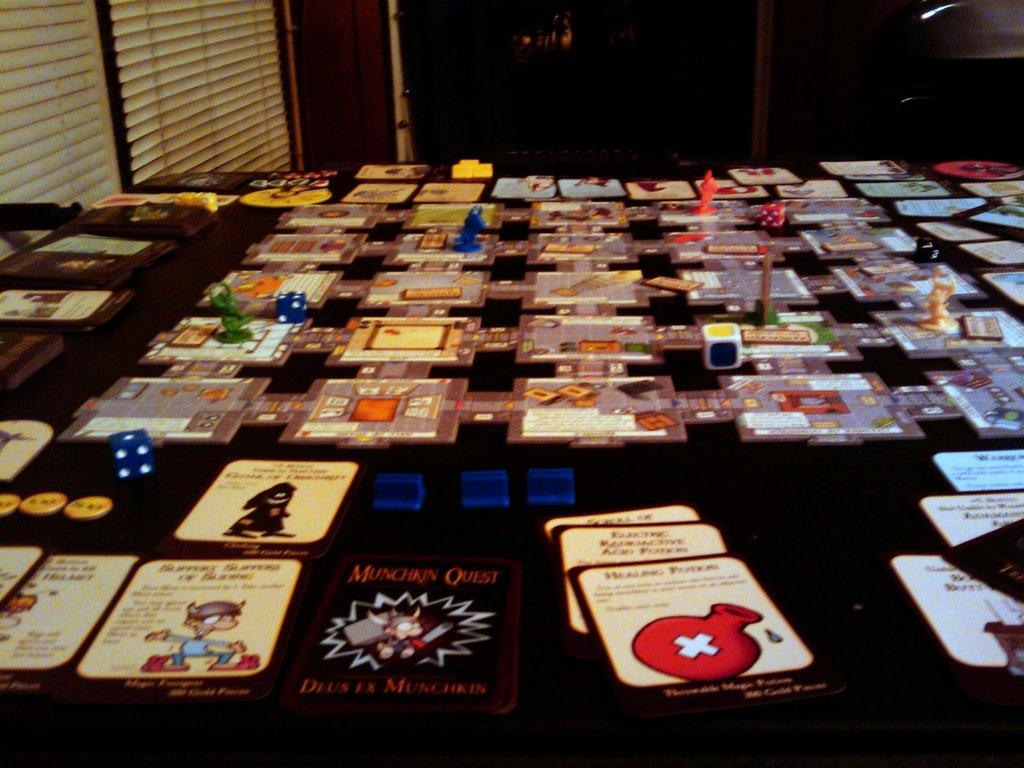What objects are placed on the table in the image? There are cars, dices, and toys on the table in the image. What type of objects can be seen in the image besides those on the table? There are curtains in the image. What is visible in the background of the image? The background of the image contains objects. How would you describe the lighting in the image? The image appears to be dark. How many cows are visible in the image? There are no cows present in the image. What type of net is used to catch the toys in the image? There is no net visible in the image, and the toys are not being caught. 